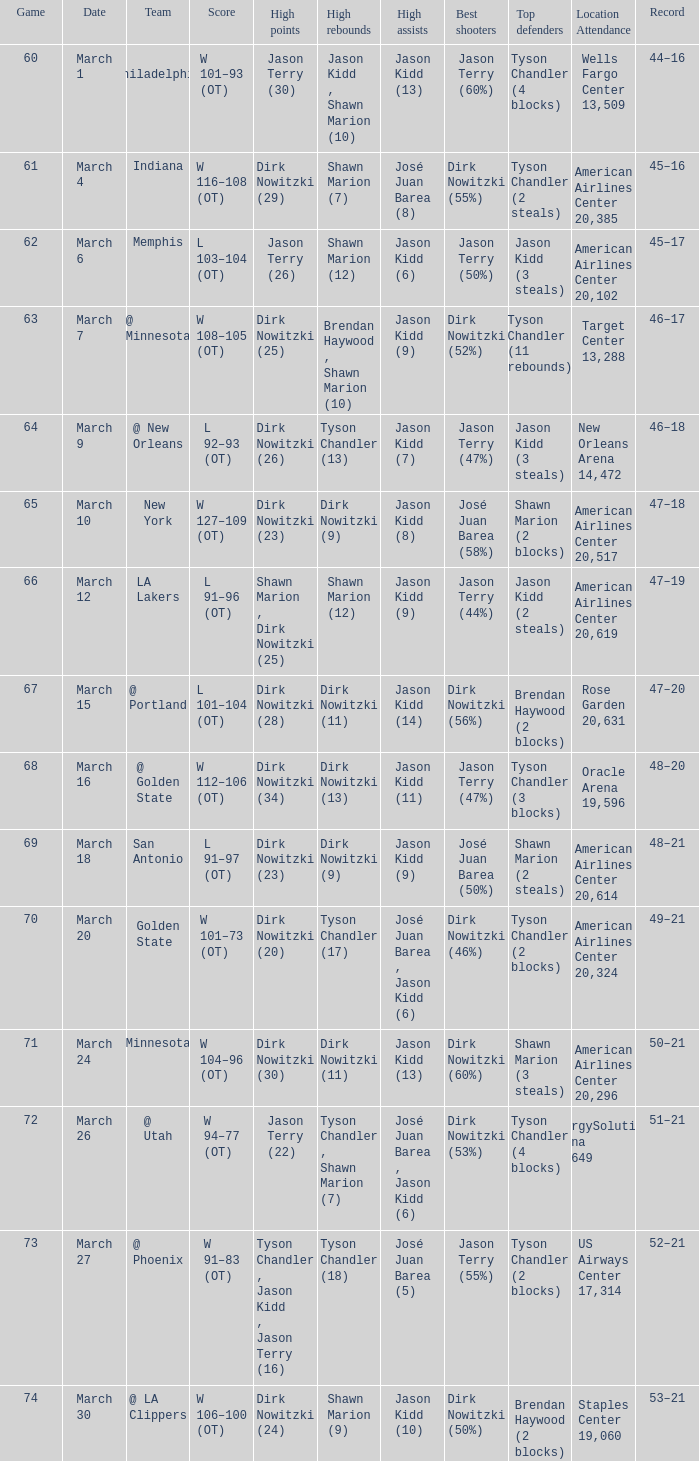Name the high points for march 30 Dirk Nowitzki (24). 